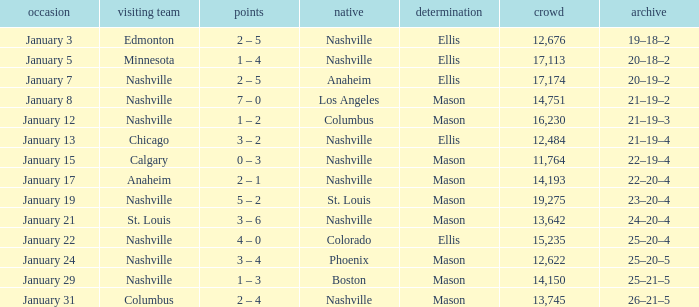On January 29, who had the decision of Mason? Nashville. 